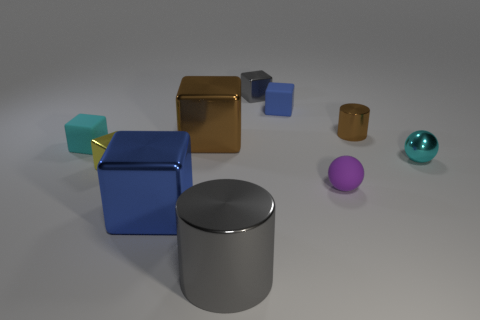Subtract all gray cubes. How many cubes are left? 5 Subtract all large blue metallic blocks. How many blocks are left? 5 Subtract all purple blocks. Subtract all purple balls. How many blocks are left? 6 Subtract all cubes. How many objects are left? 4 Add 1 large brown objects. How many large brown objects are left? 2 Add 10 gray rubber balls. How many gray rubber balls exist? 10 Subtract 1 brown blocks. How many objects are left? 9 Subtract all large blue cylinders. Subtract all metal cylinders. How many objects are left? 8 